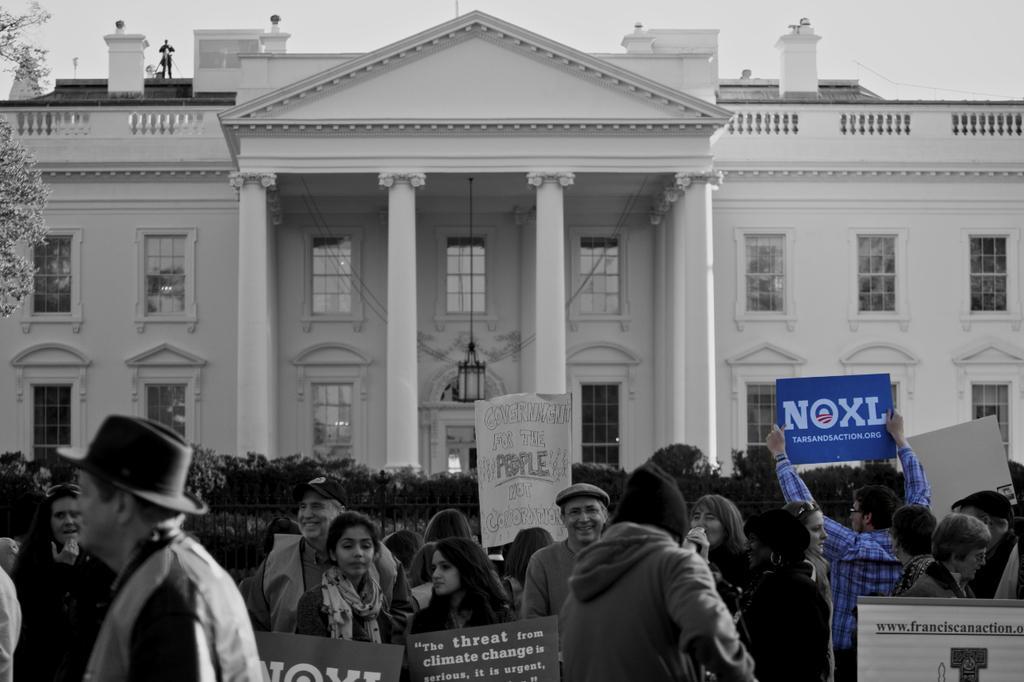Could you give a brief overview of what you see in this image? In this picture we can see some people standing in the front, some of them are holding boards, in the background there is a building, we can see windows of the building, on the left side there is a tree, this is a black and white picture. 